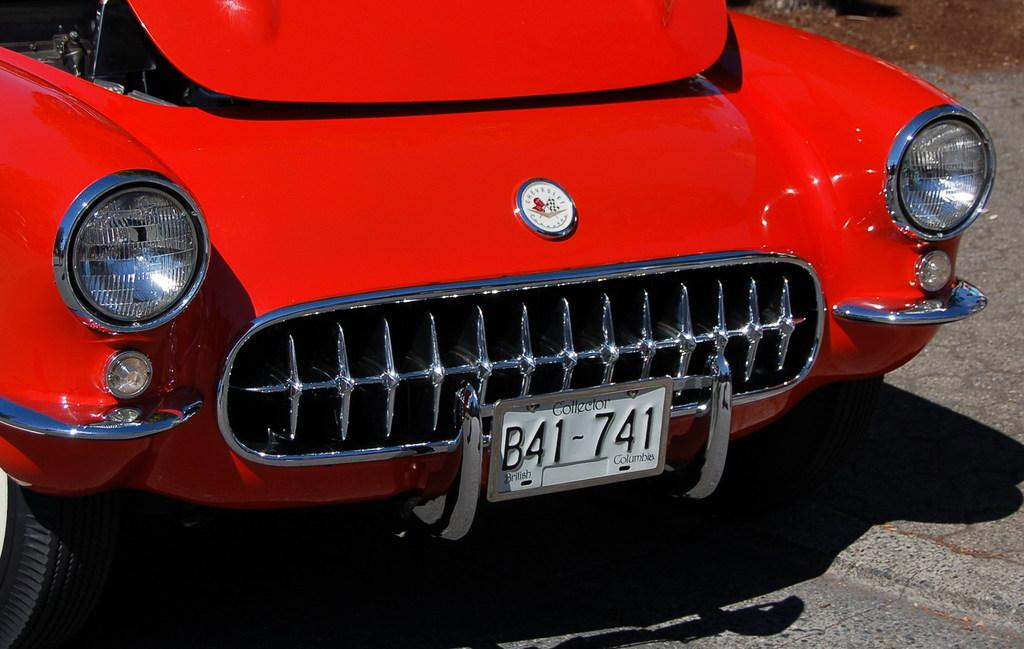What color is the car in the image? The car in the image is red. What additional feature can be seen on the car? The car has a number plate and headlights. What is the car's shadow doing in the image? The car's shadow is visible on the road in the image. Where is the pan located in the image? There is no pan present in the image. What type of alley can be seen in the image? There is no alley present in the image. 